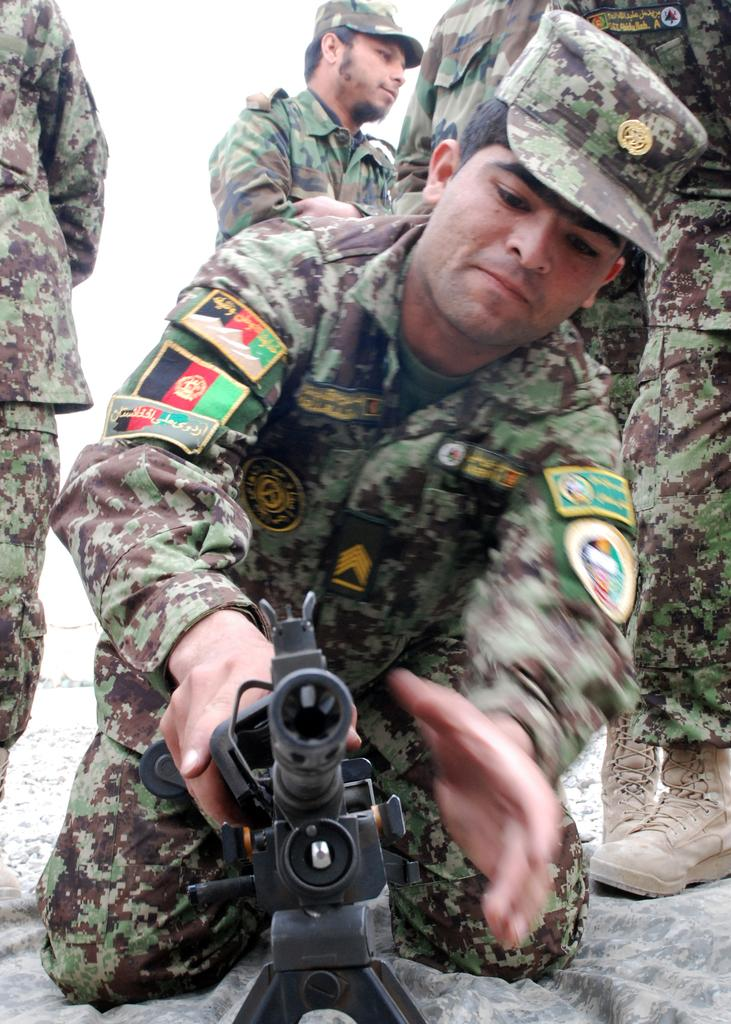What is the person in the image wearing? The person in the image is wearing a uniform and cap. What is the person doing in the image? The person is sitting. What can be seen in the image that might be used for protection or defense? There is a weapon present in the image. What can be seen in the background of the image? In the background, there are more people wearing uniforms. What type of meat is being prepared by the person's aunt in the image? There is no meat or person's aunt present in the image. What type of building is visible in the background of the image? There is no building visible in the background of the image; only more people wearing uniforms are present. 